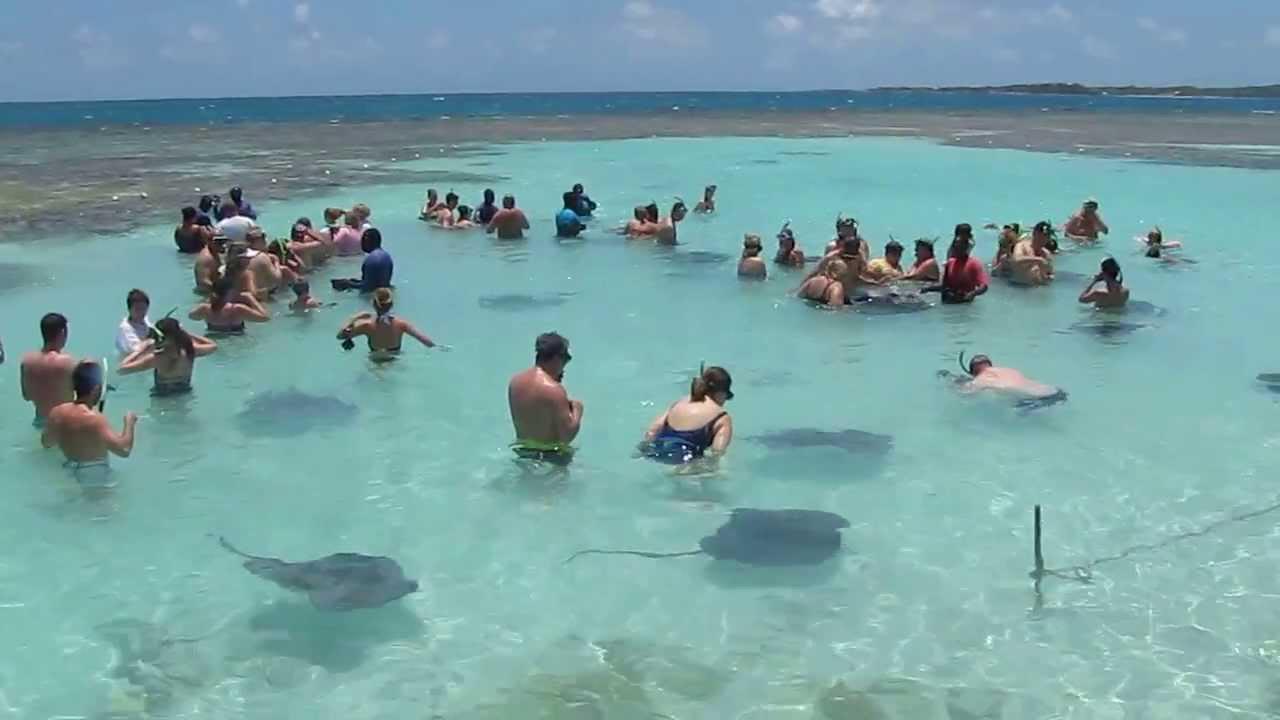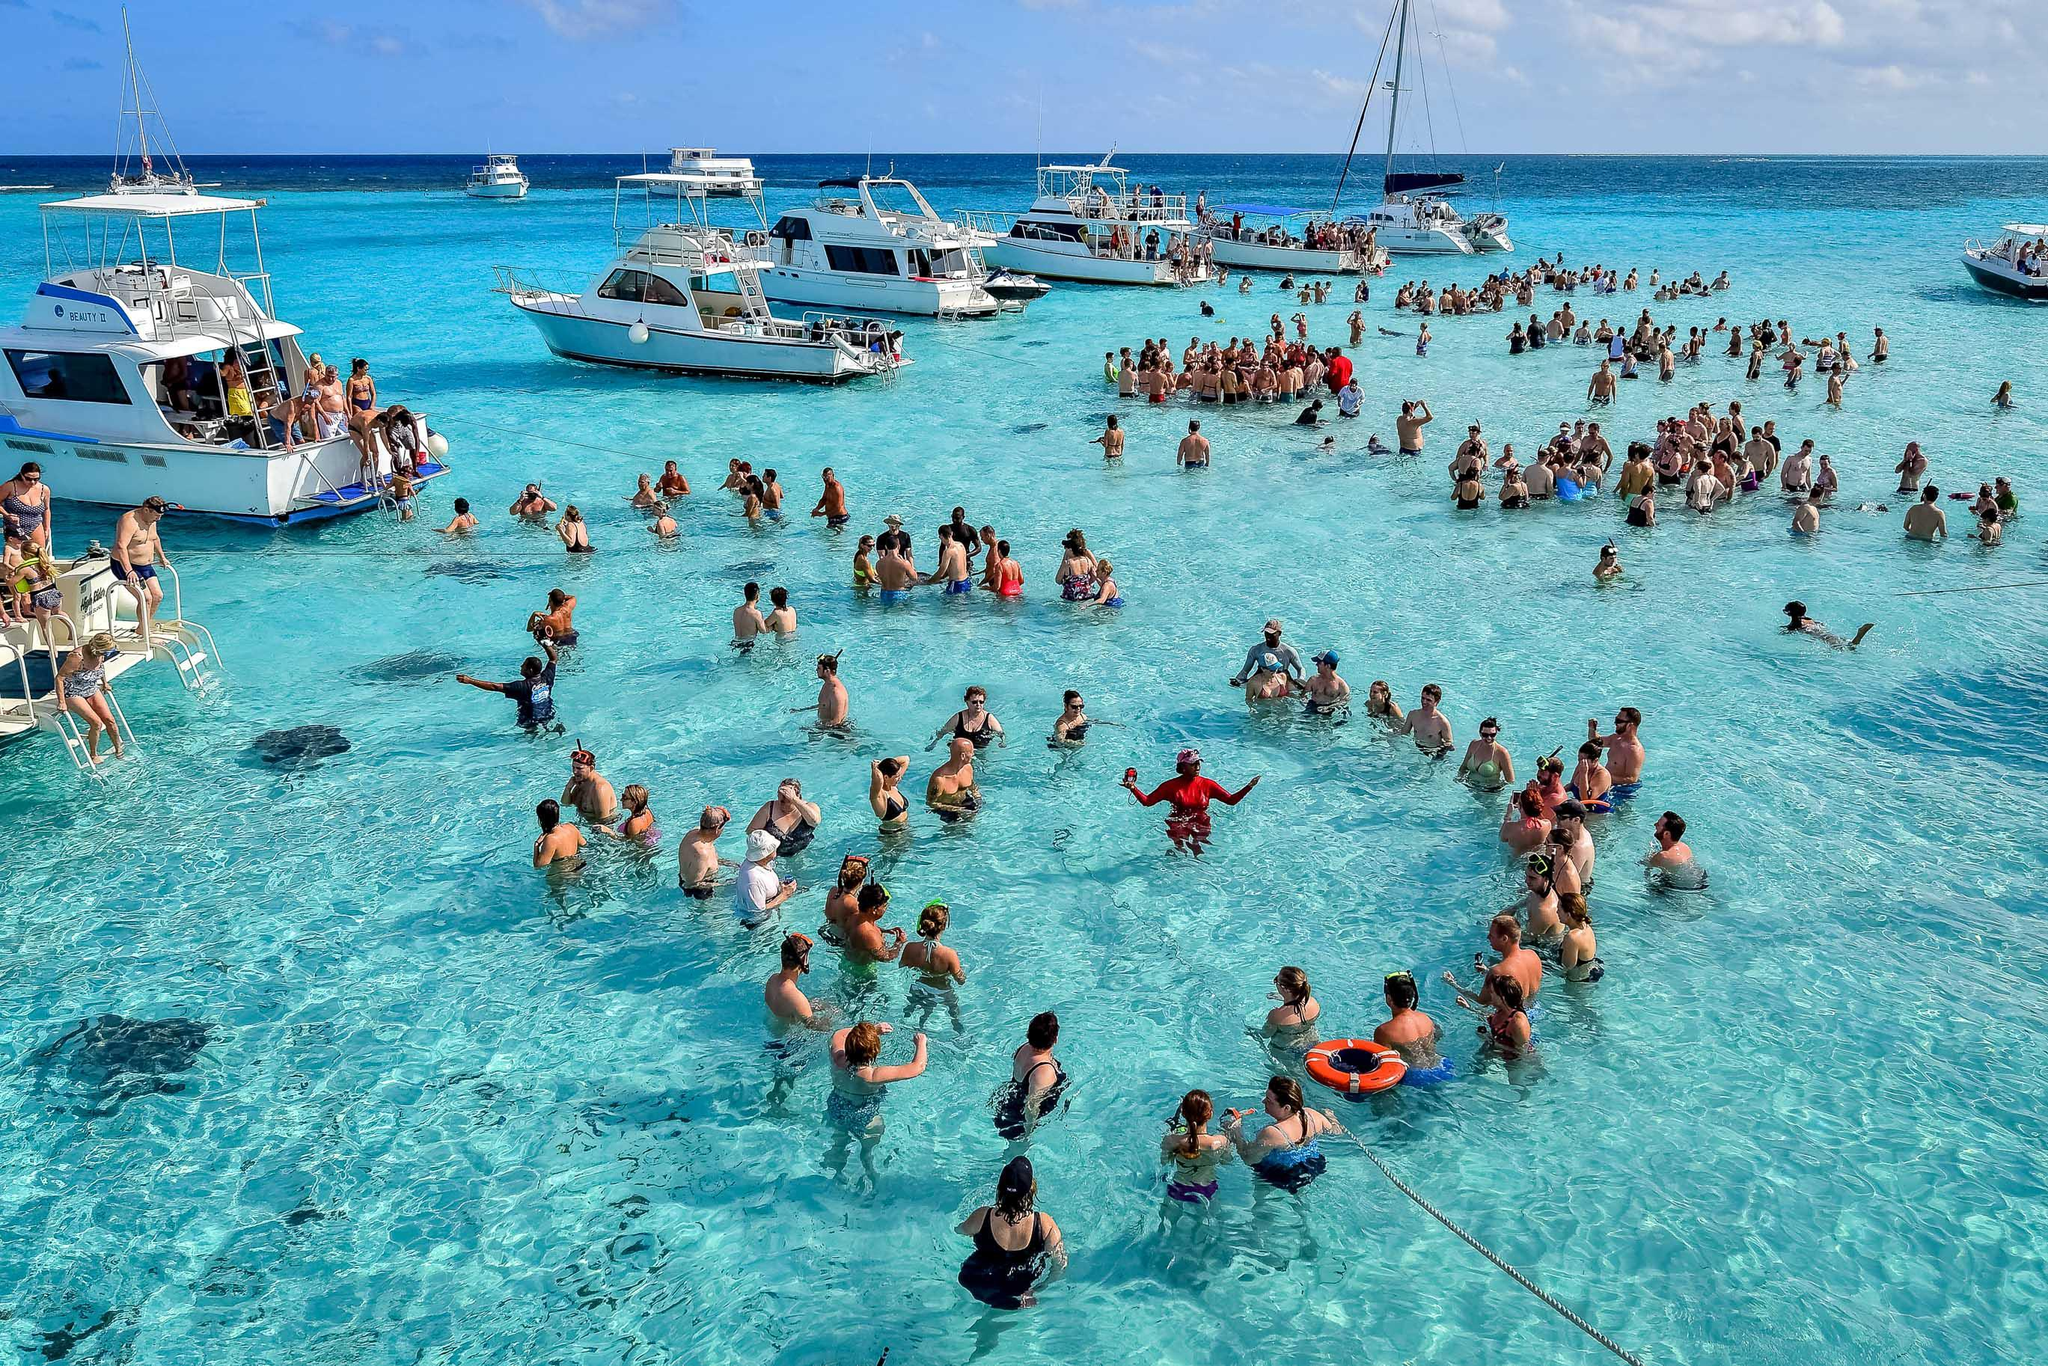The first image is the image on the left, the second image is the image on the right. Considering the images on both sides, is "In at least one image there is a man holding a stingray to the left of a little girl with goggles." valid? Answer yes or no. No. The first image is the image on the left, the second image is the image on the right. Evaluate the accuracy of this statement regarding the images: "The left image includes multiple people in the foreground, including a person with a stingray over part of their face.". Is it true? Answer yes or no. No. 